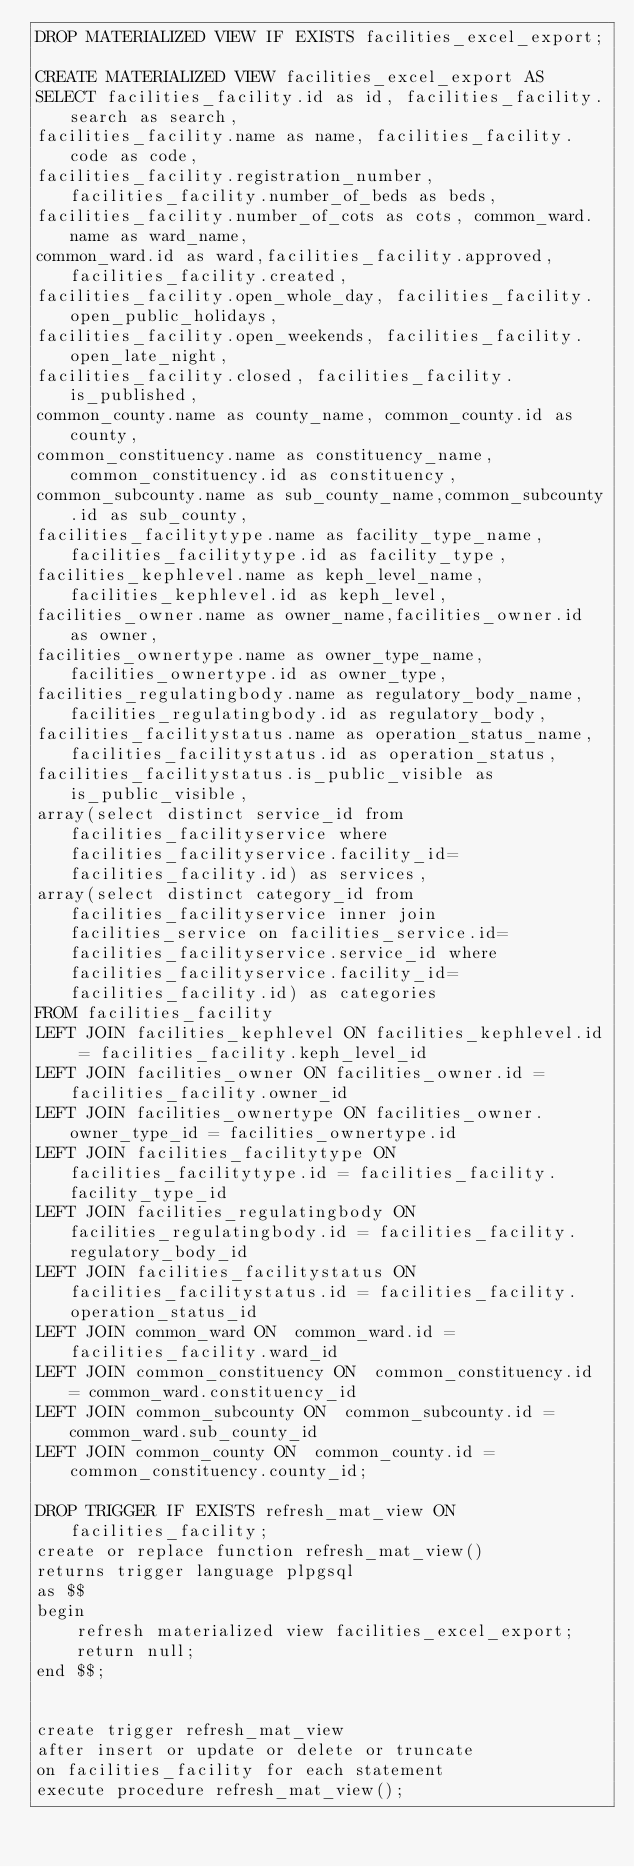Convert code to text. <code><loc_0><loc_0><loc_500><loc_500><_SQL_>DROP MATERIALIZED VIEW IF EXISTS facilities_excel_export;

CREATE MATERIALIZED VIEW facilities_excel_export AS
SELECT facilities_facility.id as id, facilities_facility.search as search,
facilities_facility.name as name, facilities_facility.code as code,
facilities_facility.registration_number, facilities_facility.number_of_beds as beds,
facilities_facility.number_of_cots as cots, common_ward.name as ward_name,
common_ward.id as ward,facilities_facility.approved,facilities_facility.created,
facilities_facility.open_whole_day, facilities_facility.open_public_holidays,
facilities_facility.open_weekends, facilities_facility.open_late_night,
facilities_facility.closed, facilities_facility.is_published,
common_county.name as county_name, common_county.id as county,
common_constituency.name as constituency_name,common_constituency.id as constituency,
common_subcounty.name as sub_county_name,common_subcounty.id as sub_county,
facilities_facilitytype.name as facility_type_name, facilities_facilitytype.id as facility_type,
facilities_kephlevel.name as keph_level_name,facilities_kephlevel.id as keph_level,
facilities_owner.name as owner_name,facilities_owner.id as owner,
facilities_ownertype.name as owner_type_name,facilities_ownertype.id as owner_type,
facilities_regulatingbody.name as regulatory_body_name,facilities_regulatingbody.id as regulatory_body,
facilities_facilitystatus.name as operation_status_name, facilities_facilitystatus.id as operation_status,
facilities_facilitystatus.is_public_visible as is_public_visible,
array(select distinct service_id from facilities_facilityservice where facilities_facilityservice.facility_id=facilities_facility.id) as services,
array(select distinct category_id from facilities_facilityservice inner join facilities_service on facilities_service.id=facilities_facilityservice.service_id where facilities_facilityservice.facility_id=facilities_facility.id) as categories
FROM facilities_facility
LEFT JOIN facilities_kephlevel ON facilities_kephlevel.id = facilities_facility.keph_level_id
LEFT JOIN facilities_owner ON facilities_owner.id = facilities_facility.owner_id
LEFT JOIN facilities_ownertype ON facilities_owner.owner_type_id = facilities_ownertype.id
LEFT JOIN facilities_facilitytype ON facilities_facilitytype.id = facilities_facility.facility_type_id
LEFT JOIN facilities_regulatingbody ON facilities_regulatingbody.id = facilities_facility.regulatory_body_id
LEFT JOIN facilities_facilitystatus ON facilities_facilitystatus.id = facilities_facility.operation_status_id
LEFT JOIN common_ward ON  common_ward.id = facilities_facility.ward_id
LEFT JOIN common_constituency ON  common_constituency.id = common_ward.constituency_id
LEFT JOIN common_subcounty ON  common_subcounty.id = common_ward.sub_county_id
LEFT JOIN common_county ON  common_county.id = common_constituency.county_id;

DROP TRIGGER IF EXISTS refresh_mat_view ON facilities_facility;
create or replace function refresh_mat_view()
returns trigger language plpgsql
as $$
begin
    refresh materialized view facilities_excel_export;
    return null;
end $$;


create trigger refresh_mat_view
after insert or update or delete or truncate
on facilities_facility for each statement
execute procedure refresh_mat_view();
</code> 